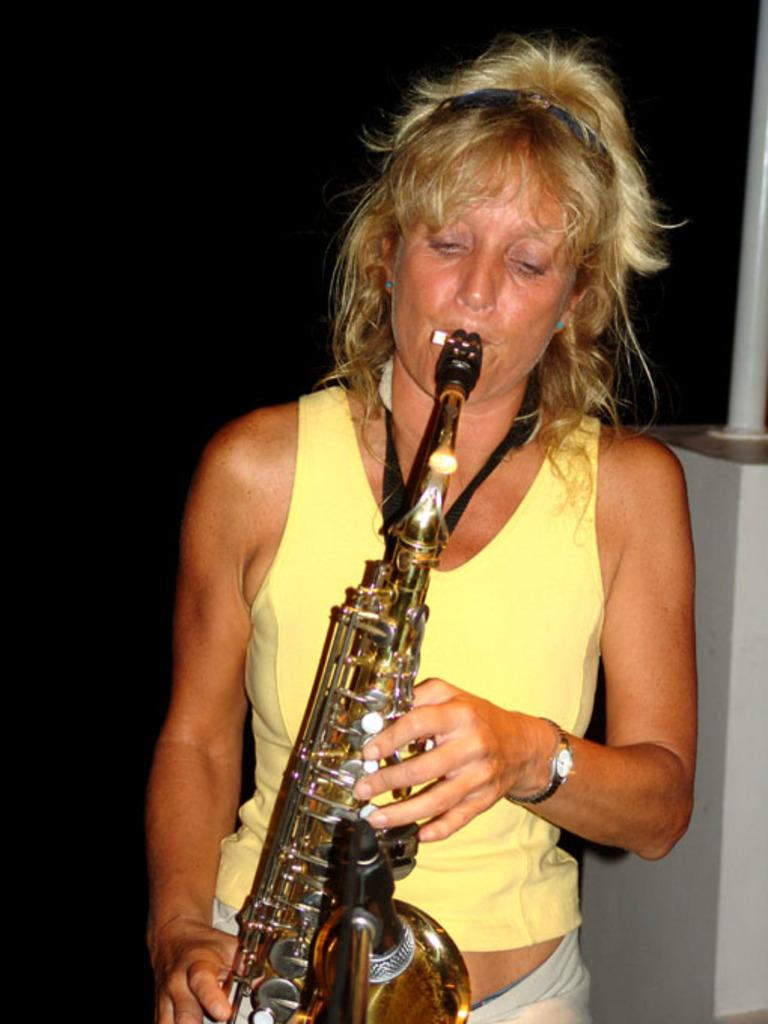Who is the main subject in the image? There is a woman in the image. What is the woman doing in the image? The woman is standing in the image. What object is the woman holding in her hands? The woman is holding a saxophone in her hands. What type of apple is the woman eating in the image? There is no apple present in the image; the woman is holding a saxophone. What position is the woman in while playing the saxophone? The image does not show the woman playing the saxophone, so we cannot determine her position while playing. 